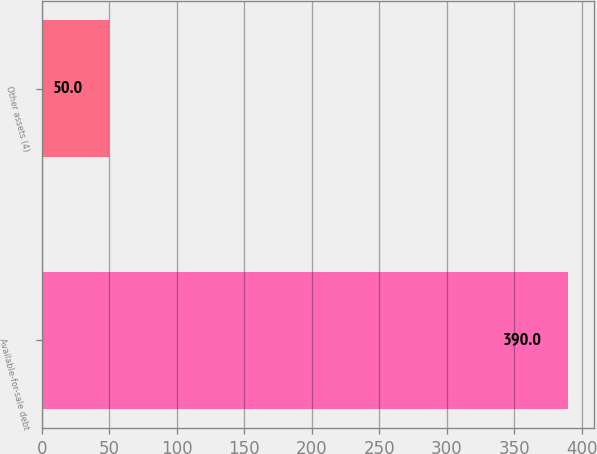<chart> <loc_0><loc_0><loc_500><loc_500><bar_chart><fcel>Available-for-sale debt<fcel>Other assets (4)<nl><fcel>390<fcel>50<nl></chart> 